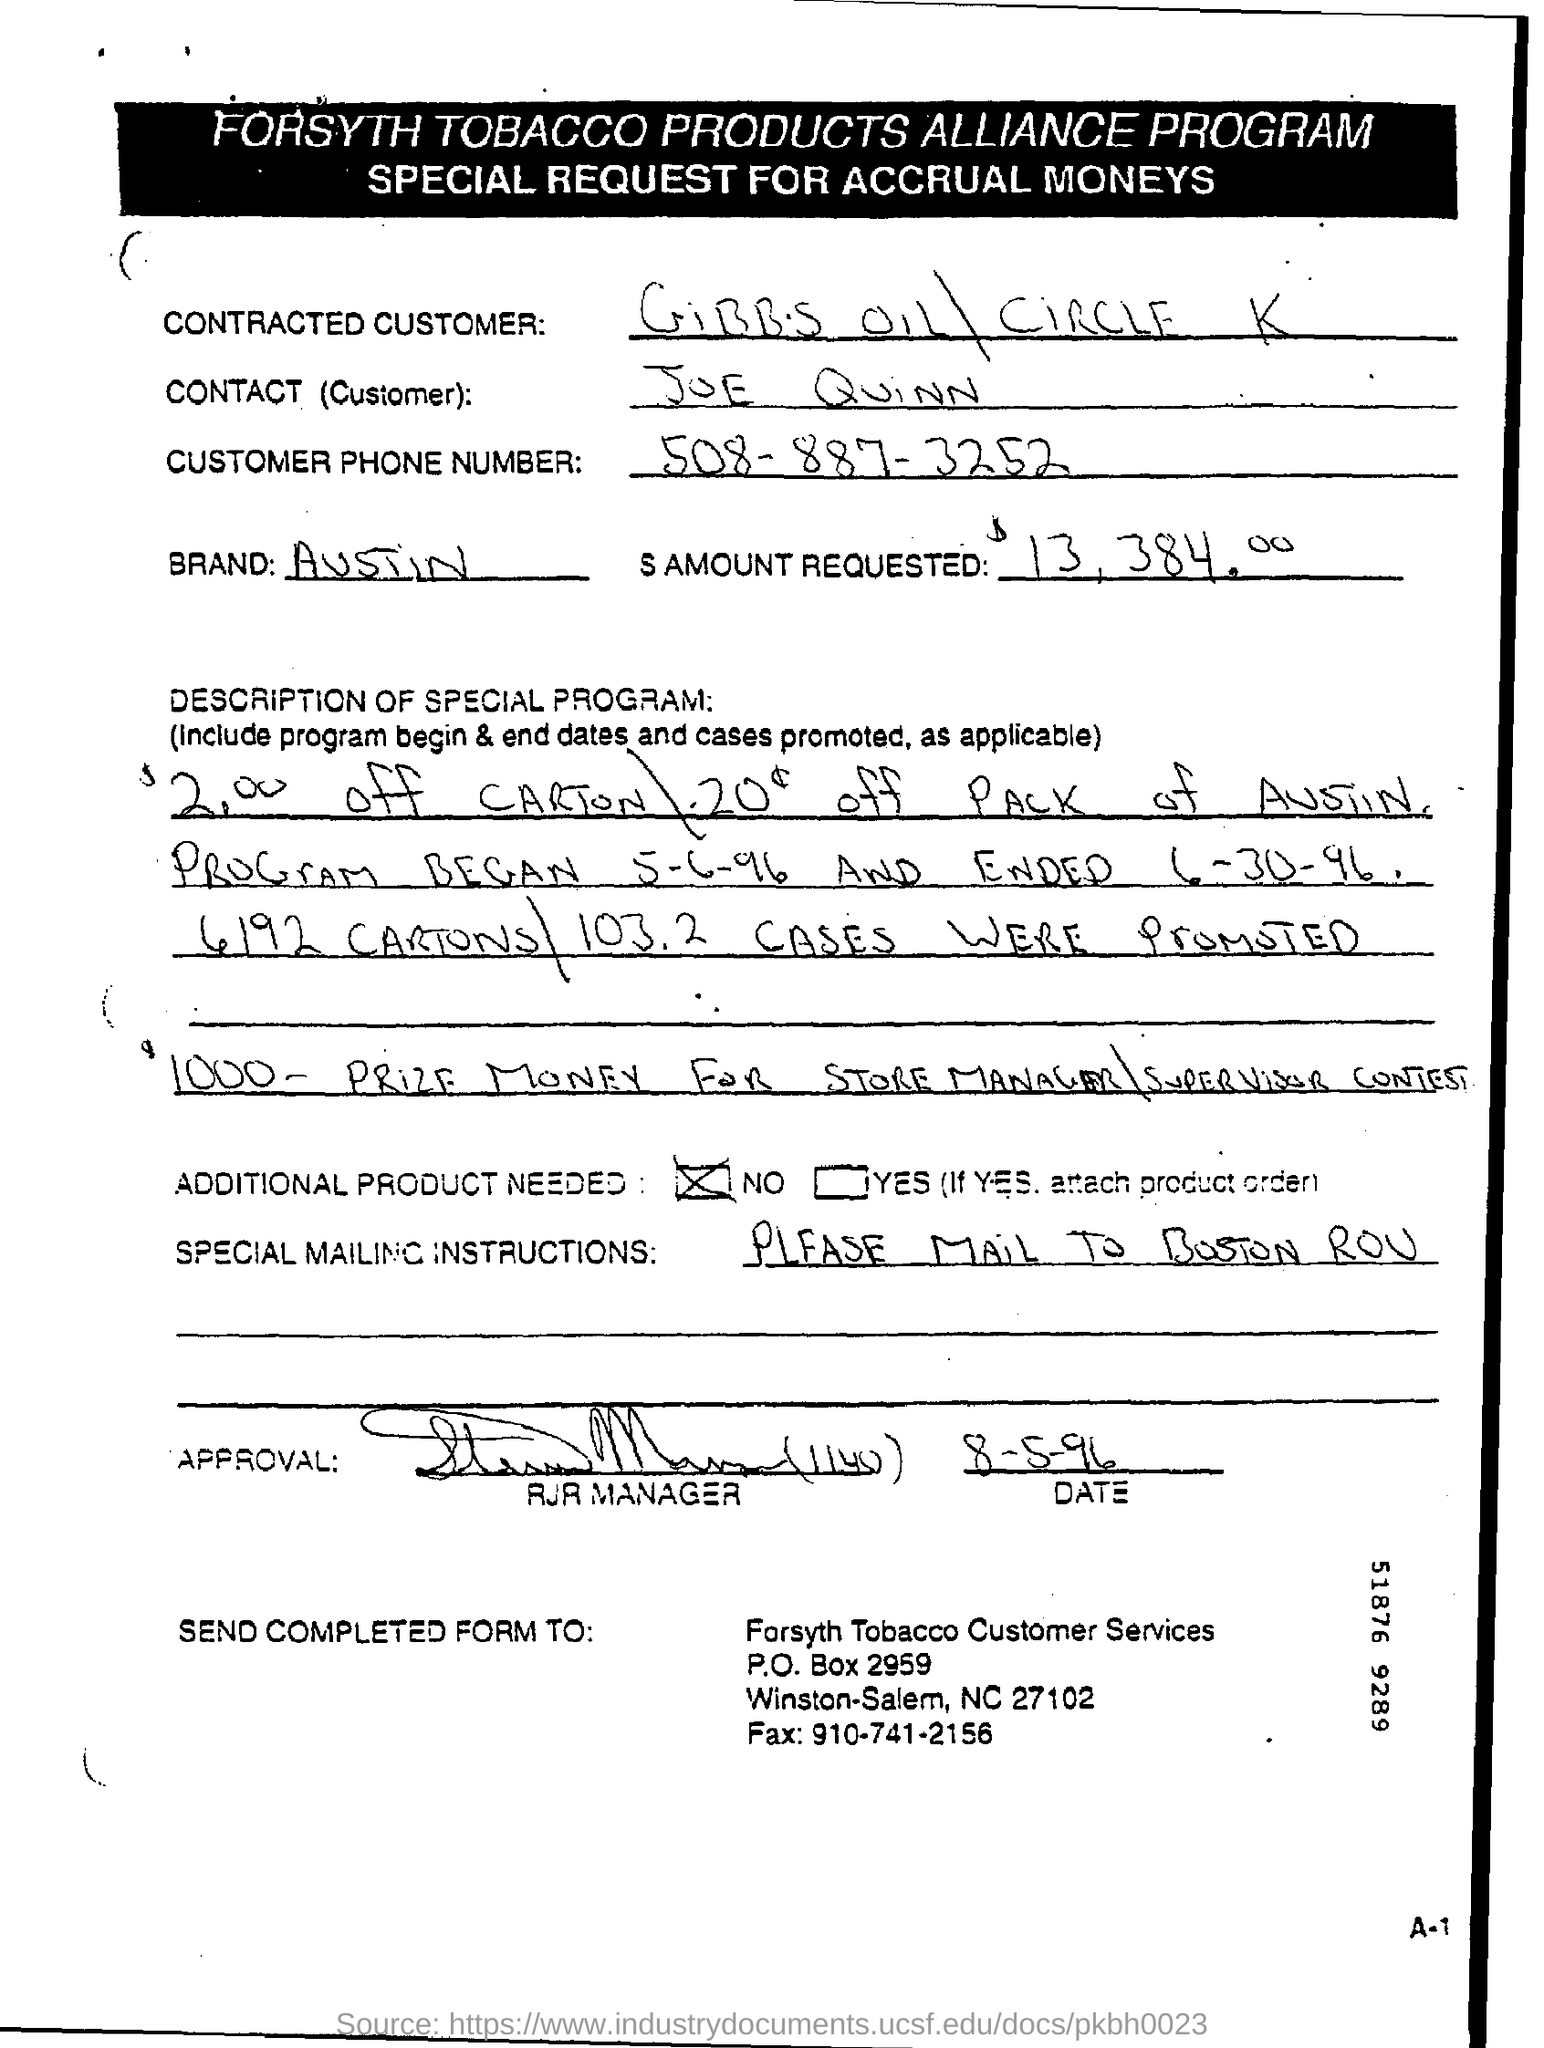Indicate a few pertinent items in this graphic. The brand name is AUSTIN. In response to the prompt "write the phone number of the customer? 508-887-3252," the customer service representative should declare, "I will write the phone number provided by the customer on a ticket as follows: 508-887-3252. The mailing instructions given are "Special" and the recipient address is "Boston ROU". The request for accrual moneys is for 13,384.00. 